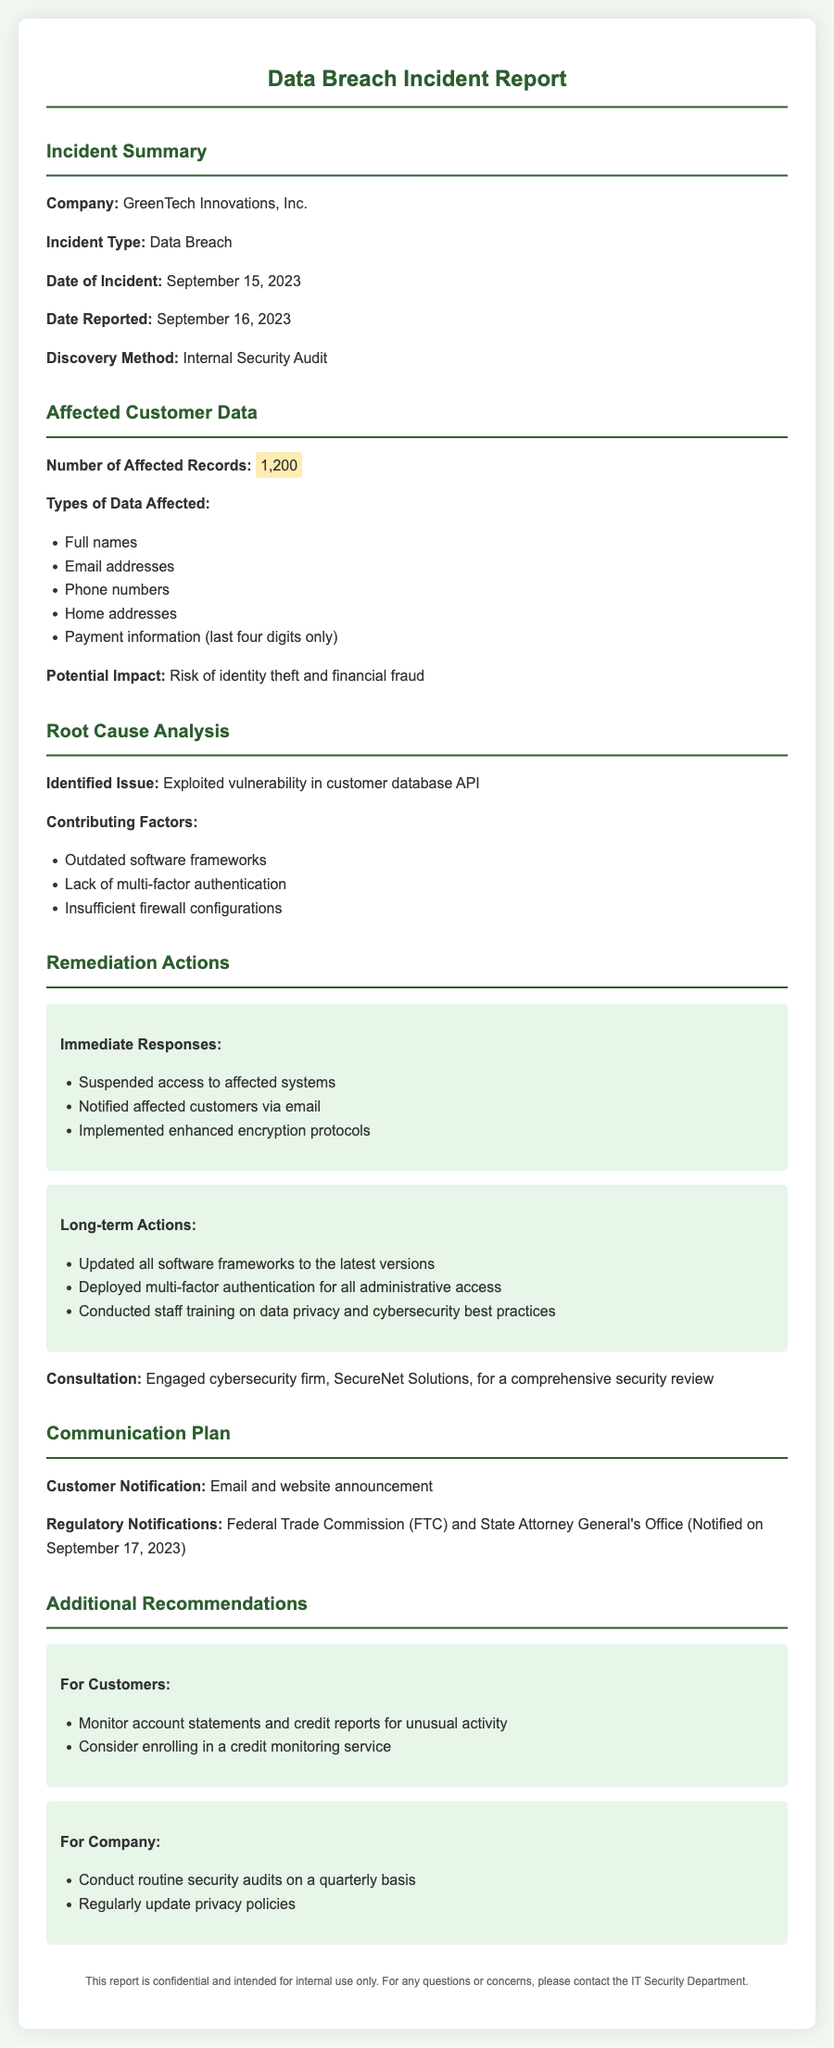What is the company name? The company name is mentioned at the beginning of the incident report.
Answer: GreenTech Innovations, Inc What type of incident occurred? The type of incident is specified in the document under "Incident Type."
Answer: Data Breach On what date did the incident occur? The date of the incident can be found in the "Date of Incident" section.
Answer: September 15, 2023 How many customer records were affected? The number of affected records is listed in the "Affected Customer Data" section.
Answer: 1,200 What was the identified issue leading to the breach? The identified issue is outlined in the "Root Cause Analysis" section.
Answer: Exploited vulnerability in customer database API What were one of the immediate responses taken? Immediate responses can be found in the "Immediate Responses" subsection under "Remediation Actions."
Answer: Suspended access to affected systems Who was engaged for a comprehensive security review? The name of the cybersecurity firm engaged is mentioned in the "Remediation Actions" section.
Answer: SecureNet Solutions What is one recommendation for customers? Recommendations for customers are found in the "Additional Recommendations" section.
Answer: Monitor account statements and credit reports for unusual activity When was the regulatory notification made? The date when regulatory notifications were made is specified in the "Communication Plan."
Answer: September 17, 2023 